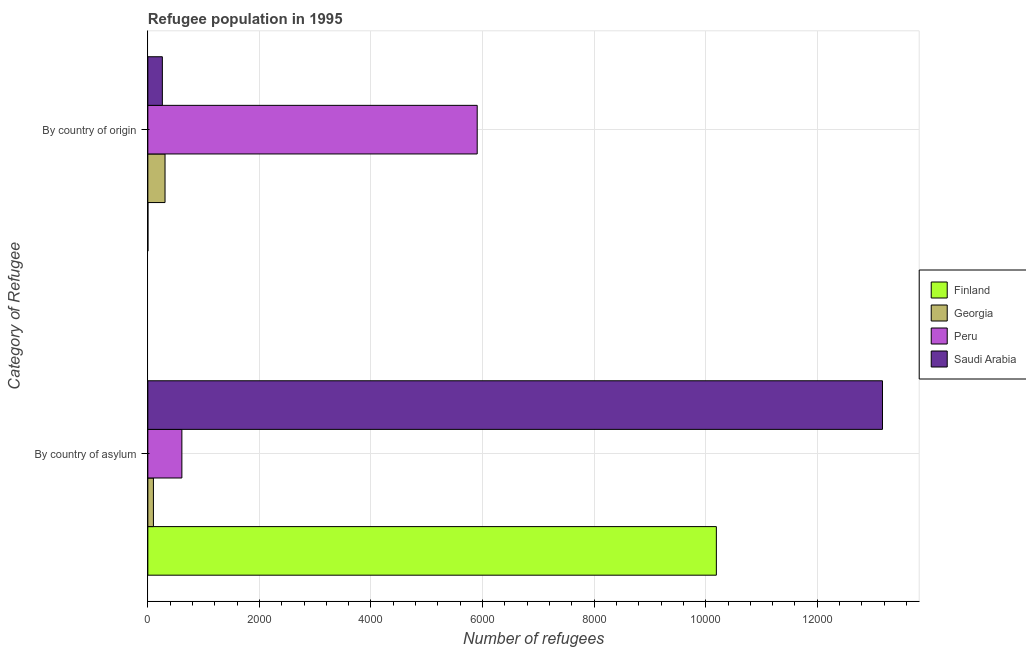How many different coloured bars are there?
Your response must be concise. 4. Are the number of bars per tick equal to the number of legend labels?
Your answer should be compact. Yes. Are the number of bars on each tick of the Y-axis equal?
Offer a terse response. Yes. How many bars are there on the 2nd tick from the top?
Make the answer very short. 4. What is the label of the 2nd group of bars from the top?
Provide a succinct answer. By country of asylum. What is the number of refugees by country of origin in Saudi Arabia?
Give a very brief answer. 260. Across all countries, what is the maximum number of refugees by country of asylum?
Your response must be concise. 1.32e+04. Across all countries, what is the minimum number of refugees by country of asylum?
Make the answer very short. 100. In which country was the number of refugees by country of asylum maximum?
Make the answer very short. Saudi Arabia. In which country was the number of refugees by country of asylum minimum?
Ensure brevity in your answer.  Georgia. What is the total number of refugees by country of asylum in the graph?
Provide a short and direct response. 2.41e+04. What is the difference between the number of refugees by country of origin in Saudi Arabia and that in Finland?
Your answer should be compact. 259. What is the difference between the number of refugees by country of origin in Georgia and the number of refugees by country of asylum in Saudi Arabia?
Provide a short and direct response. -1.29e+04. What is the average number of refugees by country of origin per country?
Your answer should be very brief. 1618.25. What is the difference between the number of refugees by country of origin and number of refugees by country of asylum in Georgia?
Provide a succinct answer. 208. What is the ratio of the number of refugees by country of asylum in Peru to that in Saudi Arabia?
Provide a short and direct response. 0.05. In how many countries, is the number of refugees by country of origin greater than the average number of refugees by country of origin taken over all countries?
Give a very brief answer. 1. What does the 3rd bar from the top in By country of origin represents?
Keep it short and to the point. Georgia. How many bars are there?
Give a very brief answer. 8. How many countries are there in the graph?
Keep it short and to the point. 4. Does the graph contain any zero values?
Your response must be concise. No. Does the graph contain grids?
Offer a very short reply. Yes. Where does the legend appear in the graph?
Offer a terse response. Center right. How are the legend labels stacked?
Ensure brevity in your answer.  Vertical. What is the title of the graph?
Ensure brevity in your answer.  Refugee population in 1995. What is the label or title of the X-axis?
Provide a succinct answer. Number of refugees. What is the label or title of the Y-axis?
Offer a terse response. Category of Refugee. What is the Number of refugees of Finland in By country of asylum?
Offer a terse response. 1.02e+04. What is the Number of refugees of Peru in By country of asylum?
Your answer should be compact. 610. What is the Number of refugees in Saudi Arabia in By country of asylum?
Your answer should be very brief. 1.32e+04. What is the Number of refugees in Georgia in By country of origin?
Keep it short and to the point. 308. What is the Number of refugees of Peru in By country of origin?
Your answer should be compact. 5904. What is the Number of refugees of Saudi Arabia in By country of origin?
Offer a terse response. 260. Across all Category of Refugee, what is the maximum Number of refugees of Finland?
Your answer should be compact. 1.02e+04. Across all Category of Refugee, what is the maximum Number of refugees of Georgia?
Provide a short and direct response. 308. Across all Category of Refugee, what is the maximum Number of refugees of Peru?
Give a very brief answer. 5904. Across all Category of Refugee, what is the maximum Number of refugees of Saudi Arabia?
Make the answer very short. 1.32e+04. Across all Category of Refugee, what is the minimum Number of refugees of Peru?
Your answer should be very brief. 610. Across all Category of Refugee, what is the minimum Number of refugees of Saudi Arabia?
Your response must be concise. 260. What is the total Number of refugees of Finland in the graph?
Offer a very short reply. 1.02e+04. What is the total Number of refugees of Georgia in the graph?
Provide a short and direct response. 408. What is the total Number of refugees of Peru in the graph?
Your answer should be compact. 6514. What is the total Number of refugees of Saudi Arabia in the graph?
Your response must be concise. 1.34e+04. What is the difference between the Number of refugees in Finland in By country of asylum and that in By country of origin?
Offer a terse response. 1.02e+04. What is the difference between the Number of refugees in Georgia in By country of asylum and that in By country of origin?
Provide a short and direct response. -208. What is the difference between the Number of refugees of Peru in By country of asylum and that in By country of origin?
Your response must be concise. -5294. What is the difference between the Number of refugees of Saudi Arabia in By country of asylum and that in By country of origin?
Ensure brevity in your answer.  1.29e+04. What is the difference between the Number of refugees in Finland in By country of asylum and the Number of refugees in Georgia in By country of origin?
Provide a succinct answer. 9883. What is the difference between the Number of refugees of Finland in By country of asylum and the Number of refugees of Peru in By country of origin?
Ensure brevity in your answer.  4287. What is the difference between the Number of refugees of Finland in By country of asylum and the Number of refugees of Saudi Arabia in By country of origin?
Provide a short and direct response. 9931. What is the difference between the Number of refugees of Georgia in By country of asylum and the Number of refugees of Peru in By country of origin?
Provide a short and direct response. -5804. What is the difference between the Number of refugees in Georgia in By country of asylum and the Number of refugees in Saudi Arabia in By country of origin?
Your answer should be very brief. -160. What is the difference between the Number of refugees in Peru in By country of asylum and the Number of refugees in Saudi Arabia in By country of origin?
Your answer should be very brief. 350. What is the average Number of refugees in Finland per Category of Refugee?
Your response must be concise. 5096. What is the average Number of refugees in Georgia per Category of Refugee?
Your answer should be compact. 204. What is the average Number of refugees in Peru per Category of Refugee?
Offer a terse response. 3257. What is the average Number of refugees in Saudi Arabia per Category of Refugee?
Your response must be concise. 6714.5. What is the difference between the Number of refugees in Finland and Number of refugees in Georgia in By country of asylum?
Your answer should be compact. 1.01e+04. What is the difference between the Number of refugees in Finland and Number of refugees in Peru in By country of asylum?
Offer a very short reply. 9581. What is the difference between the Number of refugees of Finland and Number of refugees of Saudi Arabia in By country of asylum?
Offer a terse response. -2978. What is the difference between the Number of refugees in Georgia and Number of refugees in Peru in By country of asylum?
Offer a very short reply. -510. What is the difference between the Number of refugees in Georgia and Number of refugees in Saudi Arabia in By country of asylum?
Ensure brevity in your answer.  -1.31e+04. What is the difference between the Number of refugees of Peru and Number of refugees of Saudi Arabia in By country of asylum?
Provide a succinct answer. -1.26e+04. What is the difference between the Number of refugees of Finland and Number of refugees of Georgia in By country of origin?
Make the answer very short. -307. What is the difference between the Number of refugees in Finland and Number of refugees in Peru in By country of origin?
Offer a very short reply. -5903. What is the difference between the Number of refugees of Finland and Number of refugees of Saudi Arabia in By country of origin?
Give a very brief answer. -259. What is the difference between the Number of refugees in Georgia and Number of refugees in Peru in By country of origin?
Give a very brief answer. -5596. What is the difference between the Number of refugees in Georgia and Number of refugees in Saudi Arabia in By country of origin?
Provide a short and direct response. 48. What is the difference between the Number of refugees of Peru and Number of refugees of Saudi Arabia in By country of origin?
Offer a terse response. 5644. What is the ratio of the Number of refugees in Finland in By country of asylum to that in By country of origin?
Give a very brief answer. 1.02e+04. What is the ratio of the Number of refugees in Georgia in By country of asylum to that in By country of origin?
Provide a succinct answer. 0.32. What is the ratio of the Number of refugees of Peru in By country of asylum to that in By country of origin?
Give a very brief answer. 0.1. What is the ratio of the Number of refugees of Saudi Arabia in By country of asylum to that in By country of origin?
Your answer should be compact. 50.65. What is the difference between the highest and the second highest Number of refugees in Finland?
Make the answer very short. 1.02e+04. What is the difference between the highest and the second highest Number of refugees in Georgia?
Keep it short and to the point. 208. What is the difference between the highest and the second highest Number of refugees of Peru?
Your response must be concise. 5294. What is the difference between the highest and the second highest Number of refugees of Saudi Arabia?
Provide a succinct answer. 1.29e+04. What is the difference between the highest and the lowest Number of refugees of Finland?
Your response must be concise. 1.02e+04. What is the difference between the highest and the lowest Number of refugees in Georgia?
Give a very brief answer. 208. What is the difference between the highest and the lowest Number of refugees of Peru?
Make the answer very short. 5294. What is the difference between the highest and the lowest Number of refugees of Saudi Arabia?
Keep it short and to the point. 1.29e+04. 